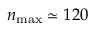<formula> <loc_0><loc_0><loc_500><loc_500>n _ { \max } \simeq 1 2 0</formula> 